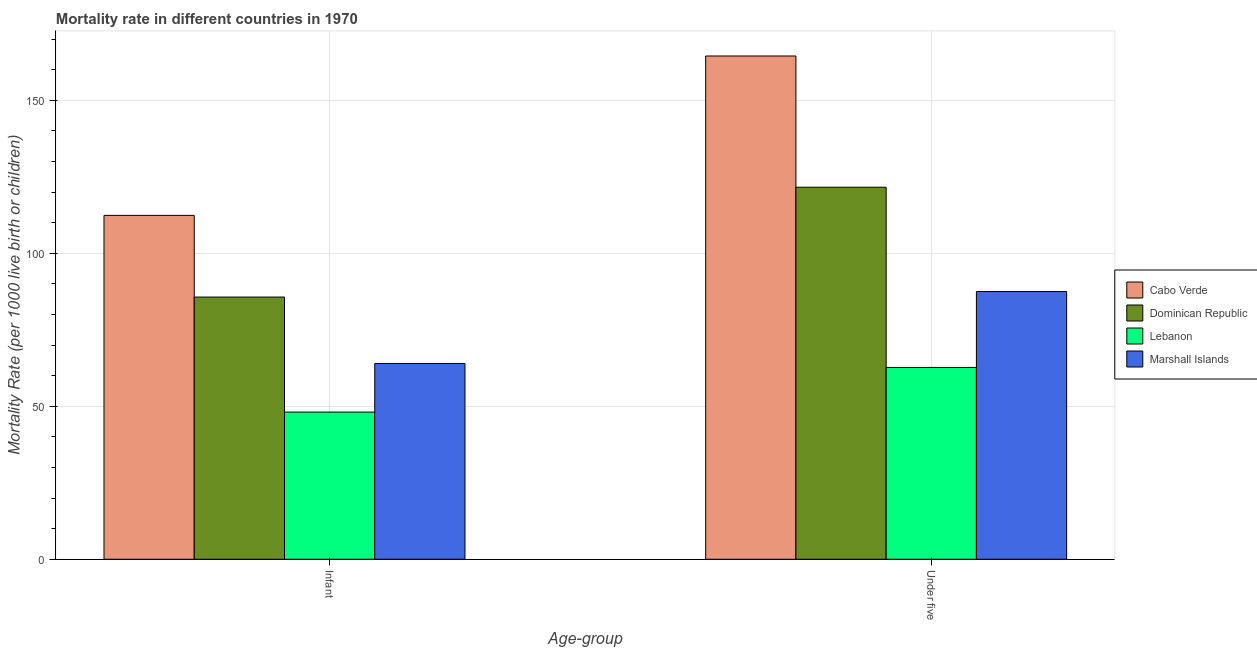Are the number of bars per tick equal to the number of legend labels?
Your answer should be compact. Yes. How many bars are there on the 1st tick from the left?
Make the answer very short. 4. How many bars are there on the 1st tick from the right?
Give a very brief answer. 4. What is the label of the 1st group of bars from the left?
Your answer should be very brief. Infant. What is the infant mortality rate in Lebanon?
Ensure brevity in your answer.  48.1. Across all countries, what is the maximum under-5 mortality rate?
Offer a very short reply. 164.5. Across all countries, what is the minimum under-5 mortality rate?
Provide a short and direct response. 62.7. In which country was the infant mortality rate maximum?
Your answer should be compact. Cabo Verde. In which country was the infant mortality rate minimum?
Your answer should be very brief. Lebanon. What is the total infant mortality rate in the graph?
Keep it short and to the point. 310.2. What is the difference between the infant mortality rate in Cabo Verde and that in Marshall Islands?
Your response must be concise. 48.4. What is the difference between the under-5 mortality rate in Dominican Republic and the infant mortality rate in Marshall Islands?
Offer a very short reply. 57.6. What is the average under-5 mortality rate per country?
Provide a short and direct response. 109.08. What is the difference between the infant mortality rate and under-5 mortality rate in Marshall Islands?
Offer a terse response. -23.5. What is the ratio of the infant mortality rate in Marshall Islands to that in Cabo Verde?
Make the answer very short. 0.57. Is the infant mortality rate in Marshall Islands less than that in Lebanon?
Offer a terse response. No. In how many countries, is the infant mortality rate greater than the average infant mortality rate taken over all countries?
Your response must be concise. 2. What does the 1st bar from the left in Infant represents?
Offer a terse response. Cabo Verde. What does the 1st bar from the right in Under five represents?
Your response must be concise. Marshall Islands. How many bars are there?
Keep it short and to the point. 8. How many countries are there in the graph?
Ensure brevity in your answer.  4. Does the graph contain any zero values?
Keep it short and to the point. No. Where does the legend appear in the graph?
Ensure brevity in your answer.  Center right. How are the legend labels stacked?
Offer a very short reply. Vertical. What is the title of the graph?
Keep it short and to the point. Mortality rate in different countries in 1970. What is the label or title of the X-axis?
Offer a terse response. Age-group. What is the label or title of the Y-axis?
Your answer should be compact. Mortality Rate (per 1000 live birth or children). What is the Mortality Rate (per 1000 live birth or children) of Cabo Verde in Infant?
Your answer should be compact. 112.4. What is the Mortality Rate (per 1000 live birth or children) in Dominican Republic in Infant?
Your answer should be very brief. 85.7. What is the Mortality Rate (per 1000 live birth or children) of Lebanon in Infant?
Ensure brevity in your answer.  48.1. What is the Mortality Rate (per 1000 live birth or children) in Cabo Verde in Under five?
Offer a terse response. 164.5. What is the Mortality Rate (per 1000 live birth or children) in Dominican Republic in Under five?
Your response must be concise. 121.6. What is the Mortality Rate (per 1000 live birth or children) in Lebanon in Under five?
Give a very brief answer. 62.7. What is the Mortality Rate (per 1000 live birth or children) of Marshall Islands in Under five?
Your answer should be very brief. 87.5. Across all Age-group, what is the maximum Mortality Rate (per 1000 live birth or children) of Cabo Verde?
Your answer should be very brief. 164.5. Across all Age-group, what is the maximum Mortality Rate (per 1000 live birth or children) of Dominican Republic?
Keep it short and to the point. 121.6. Across all Age-group, what is the maximum Mortality Rate (per 1000 live birth or children) in Lebanon?
Provide a succinct answer. 62.7. Across all Age-group, what is the maximum Mortality Rate (per 1000 live birth or children) in Marshall Islands?
Offer a terse response. 87.5. Across all Age-group, what is the minimum Mortality Rate (per 1000 live birth or children) of Cabo Verde?
Your answer should be very brief. 112.4. Across all Age-group, what is the minimum Mortality Rate (per 1000 live birth or children) in Dominican Republic?
Ensure brevity in your answer.  85.7. Across all Age-group, what is the minimum Mortality Rate (per 1000 live birth or children) in Lebanon?
Make the answer very short. 48.1. What is the total Mortality Rate (per 1000 live birth or children) in Cabo Verde in the graph?
Your answer should be compact. 276.9. What is the total Mortality Rate (per 1000 live birth or children) of Dominican Republic in the graph?
Your response must be concise. 207.3. What is the total Mortality Rate (per 1000 live birth or children) of Lebanon in the graph?
Offer a very short reply. 110.8. What is the total Mortality Rate (per 1000 live birth or children) of Marshall Islands in the graph?
Ensure brevity in your answer.  151.5. What is the difference between the Mortality Rate (per 1000 live birth or children) in Cabo Verde in Infant and that in Under five?
Make the answer very short. -52.1. What is the difference between the Mortality Rate (per 1000 live birth or children) in Dominican Republic in Infant and that in Under five?
Provide a short and direct response. -35.9. What is the difference between the Mortality Rate (per 1000 live birth or children) in Lebanon in Infant and that in Under five?
Provide a short and direct response. -14.6. What is the difference between the Mortality Rate (per 1000 live birth or children) of Marshall Islands in Infant and that in Under five?
Provide a short and direct response. -23.5. What is the difference between the Mortality Rate (per 1000 live birth or children) in Cabo Verde in Infant and the Mortality Rate (per 1000 live birth or children) in Dominican Republic in Under five?
Give a very brief answer. -9.2. What is the difference between the Mortality Rate (per 1000 live birth or children) in Cabo Verde in Infant and the Mortality Rate (per 1000 live birth or children) in Lebanon in Under five?
Ensure brevity in your answer.  49.7. What is the difference between the Mortality Rate (per 1000 live birth or children) of Cabo Verde in Infant and the Mortality Rate (per 1000 live birth or children) of Marshall Islands in Under five?
Offer a very short reply. 24.9. What is the difference between the Mortality Rate (per 1000 live birth or children) of Lebanon in Infant and the Mortality Rate (per 1000 live birth or children) of Marshall Islands in Under five?
Make the answer very short. -39.4. What is the average Mortality Rate (per 1000 live birth or children) in Cabo Verde per Age-group?
Make the answer very short. 138.45. What is the average Mortality Rate (per 1000 live birth or children) of Dominican Republic per Age-group?
Provide a short and direct response. 103.65. What is the average Mortality Rate (per 1000 live birth or children) of Lebanon per Age-group?
Make the answer very short. 55.4. What is the average Mortality Rate (per 1000 live birth or children) in Marshall Islands per Age-group?
Give a very brief answer. 75.75. What is the difference between the Mortality Rate (per 1000 live birth or children) of Cabo Verde and Mortality Rate (per 1000 live birth or children) of Dominican Republic in Infant?
Keep it short and to the point. 26.7. What is the difference between the Mortality Rate (per 1000 live birth or children) in Cabo Verde and Mortality Rate (per 1000 live birth or children) in Lebanon in Infant?
Offer a terse response. 64.3. What is the difference between the Mortality Rate (per 1000 live birth or children) in Cabo Verde and Mortality Rate (per 1000 live birth or children) in Marshall Islands in Infant?
Your answer should be very brief. 48.4. What is the difference between the Mortality Rate (per 1000 live birth or children) in Dominican Republic and Mortality Rate (per 1000 live birth or children) in Lebanon in Infant?
Keep it short and to the point. 37.6. What is the difference between the Mortality Rate (per 1000 live birth or children) in Dominican Republic and Mortality Rate (per 1000 live birth or children) in Marshall Islands in Infant?
Offer a terse response. 21.7. What is the difference between the Mortality Rate (per 1000 live birth or children) of Lebanon and Mortality Rate (per 1000 live birth or children) of Marshall Islands in Infant?
Offer a terse response. -15.9. What is the difference between the Mortality Rate (per 1000 live birth or children) in Cabo Verde and Mortality Rate (per 1000 live birth or children) in Dominican Republic in Under five?
Offer a terse response. 42.9. What is the difference between the Mortality Rate (per 1000 live birth or children) in Cabo Verde and Mortality Rate (per 1000 live birth or children) in Lebanon in Under five?
Give a very brief answer. 101.8. What is the difference between the Mortality Rate (per 1000 live birth or children) in Cabo Verde and Mortality Rate (per 1000 live birth or children) in Marshall Islands in Under five?
Give a very brief answer. 77. What is the difference between the Mortality Rate (per 1000 live birth or children) of Dominican Republic and Mortality Rate (per 1000 live birth or children) of Lebanon in Under five?
Provide a succinct answer. 58.9. What is the difference between the Mortality Rate (per 1000 live birth or children) of Dominican Republic and Mortality Rate (per 1000 live birth or children) of Marshall Islands in Under five?
Offer a terse response. 34.1. What is the difference between the Mortality Rate (per 1000 live birth or children) of Lebanon and Mortality Rate (per 1000 live birth or children) of Marshall Islands in Under five?
Your response must be concise. -24.8. What is the ratio of the Mortality Rate (per 1000 live birth or children) in Cabo Verde in Infant to that in Under five?
Ensure brevity in your answer.  0.68. What is the ratio of the Mortality Rate (per 1000 live birth or children) in Dominican Republic in Infant to that in Under five?
Ensure brevity in your answer.  0.7. What is the ratio of the Mortality Rate (per 1000 live birth or children) in Lebanon in Infant to that in Under five?
Provide a succinct answer. 0.77. What is the ratio of the Mortality Rate (per 1000 live birth or children) of Marshall Islands in Infant to that in Under five?
Make the answer very short. 0.73. What is the difference between the highest and the second highest Mortality Rate (per 1000 live birth or children) in Cabo Verde?
Provide a succinct answer. 52.1. What is the difference between the highest and the second highest Mortality Rate (per 1000 live birth or children) in Dominican Republic?
Make the answer very short. 35.9. What is the difference between the highest and the second highest Mortality Rate (per 1000 live birth or children) of Lebanon?
Your response must be concise. 14.6. What is the difference between the highest and the second highest Mortality Rate (per 1000 live birth or children) in Marshall Islands?
Make the answer very short. 23.5. What is the difference between the highest and the lowest Mortality Rate (per 1000 live birth or children) in Cabo Verde?
Provide a succinct answer. 52.1. What is the difference between the highest and the lowest Mortality Rate (per 1000 live birth or children) in Dominican Republic?
Keep it short and to the point. 35.9. What is the difference between the highest and the lowest Mortality Rate (per 1000 live birth or children) of Lebanon?
Give a very brief answer. 14.6. 